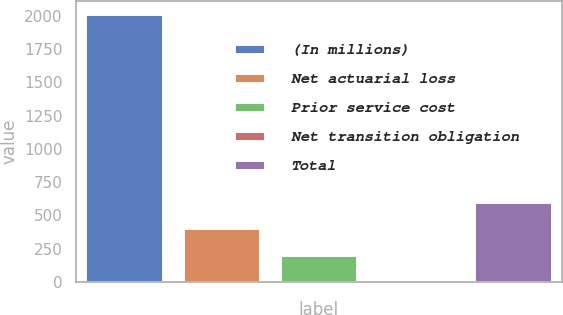<chart> <loc_0><loc_0><loc_500><loc_500><bar_chart><fcel>(In millions)<fcel>Net actuarial loss<fcel>Prior service cost<fcel>Net transition obligation<fcel>Total<nl><fcel>2010<fcel>402.8<fcel>201.9<fcel>1<fcel>603.7<nl></chart> 